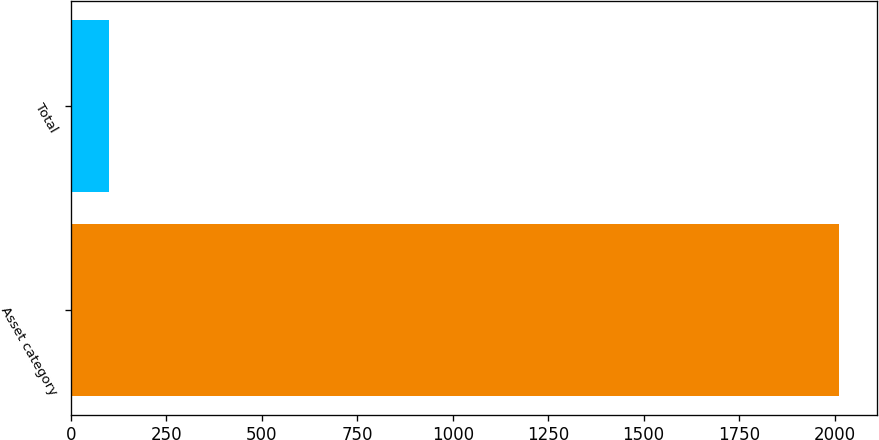Convert chart to OTSL. <chart><loc_0><loc_0><loc_500><loc_500><bar_chart><fcel>Asset category<fcel>Total<nl><fcel>2011<fcel>100<nl></chart> 